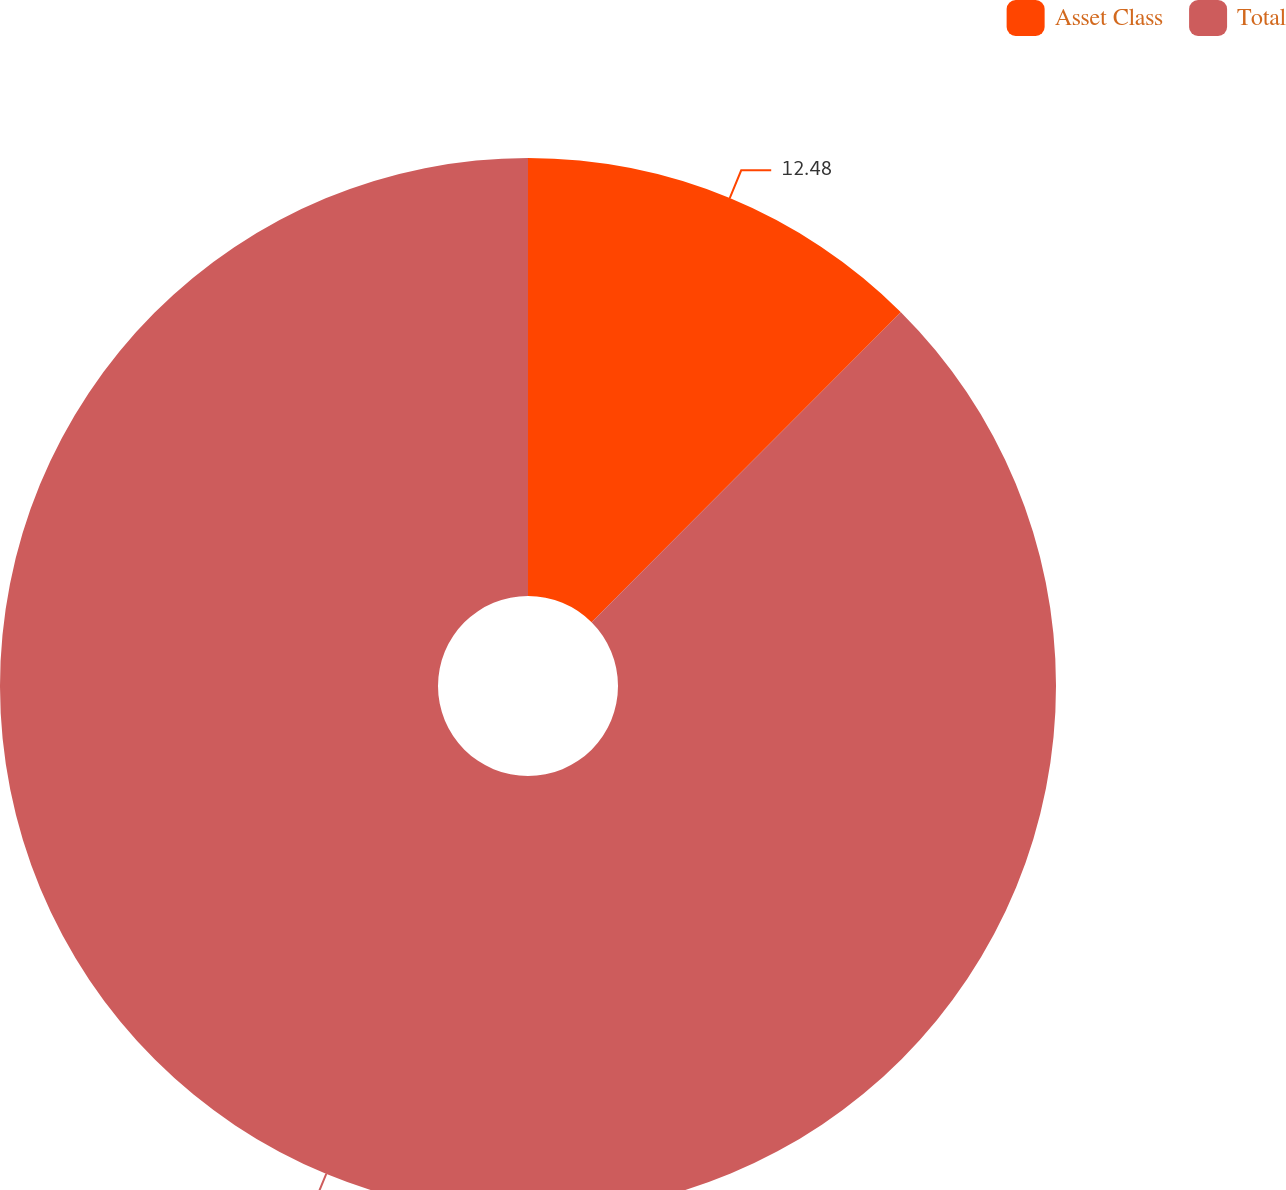Convert chart. <chart><loc_0><loc_0><loc_500><loc_500><pie_chart><fcel>Asset Class<fcel>Total<nl><fcel>12.48%<fcel>87.52%<nl></chart> 